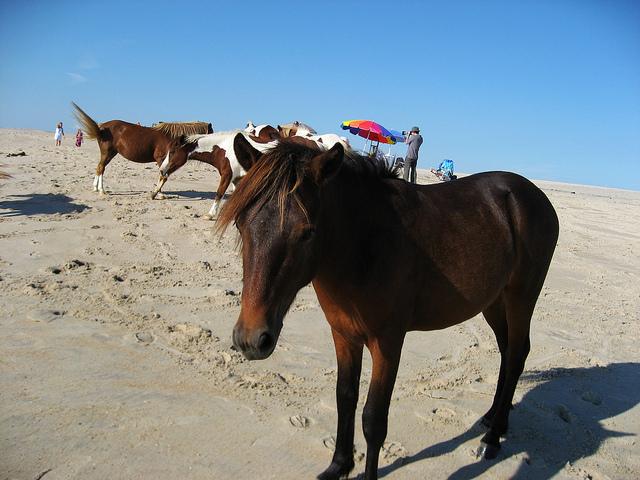What animal is facing the camera?
Write a very short answer. Horse. How many animals can be seen?
Keep it brief. 3. How many horses?
Write a very short answer. 3. Is this horse being ridden by Obama in the photo?
Quick response, please. No. Sunny or overcast?
Quick response, please. Sunny. Where is the horse?
Answer briefly. Beach. Why is the horse on the beach?
Be succinct. Being rode. What kind of animal is in the foreground?
Quick response, please. Horse. 